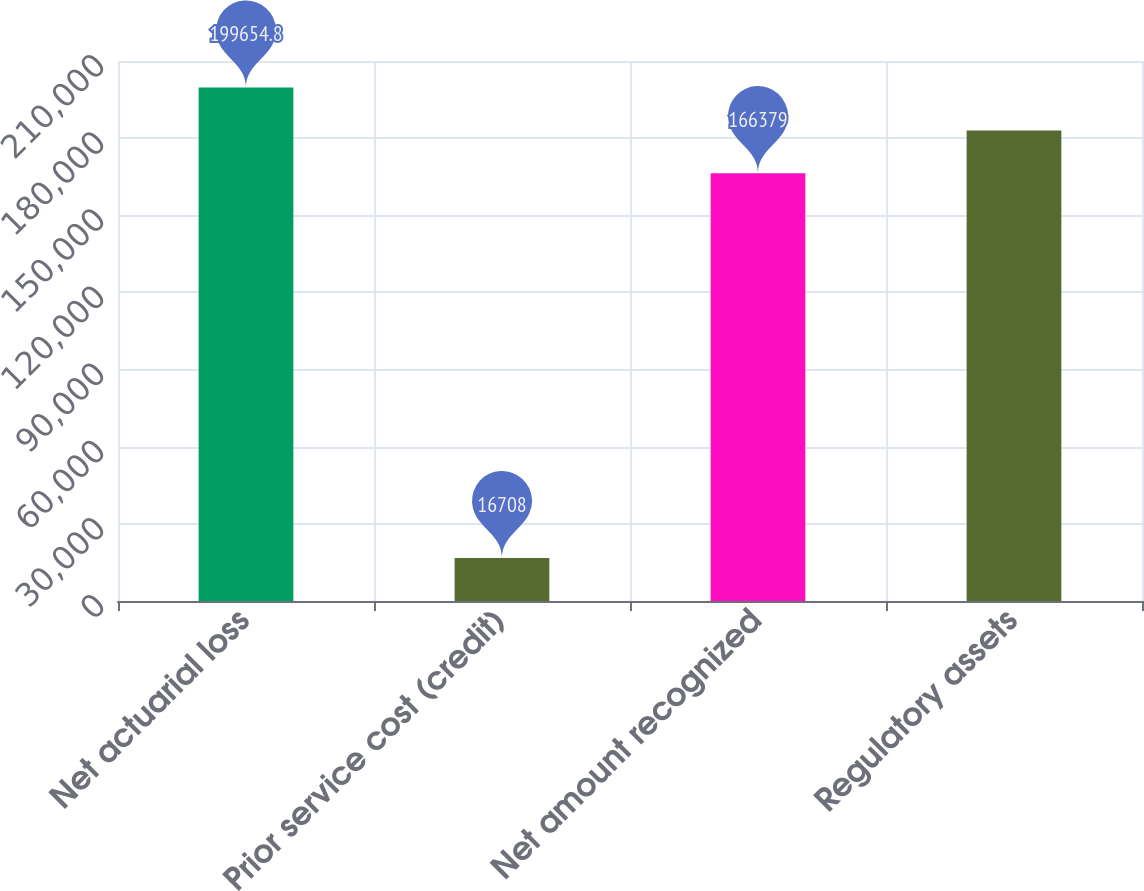Convert chart to OTSL. <chart><loc_0><loc_0><loc_500><loc_500><bar_chart><fcel>Net actuarial loss<fcel>Prior service cost (credit)<fcel>Net amount recognized<fcel>Regulatory assets<nl><fcel>199655<fcel>16708<fcel>166379<fcel>183017<nl></chart> 